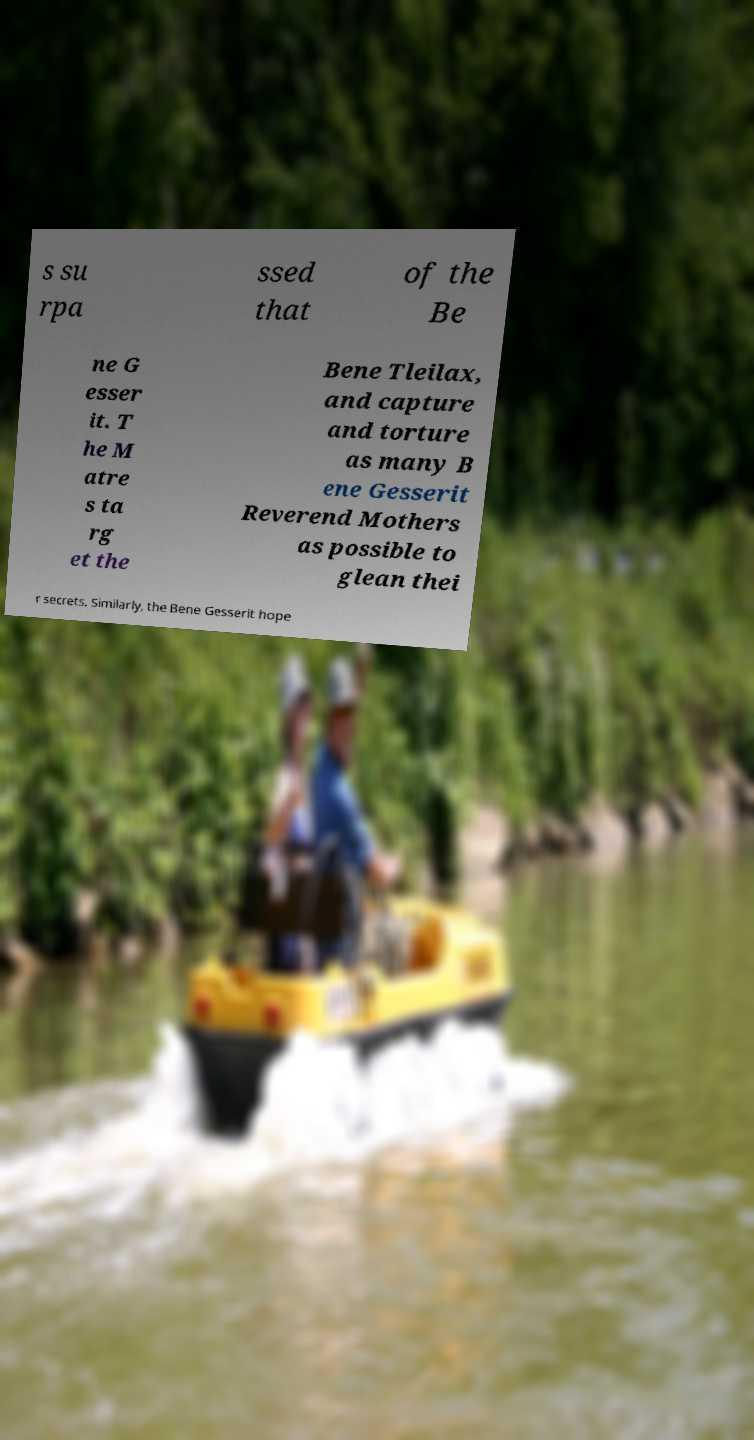I need the written content from this picture converted into text. Can you do that? s su rpa ssed that of the Be ne G esser it. T he M atre s ta rg et the Bene Tleilax, and capture and torture as many B ene Gesserit Reverend Mothers as possible to glean thei r secrets. Similarly, the Bene Gesserit hope 